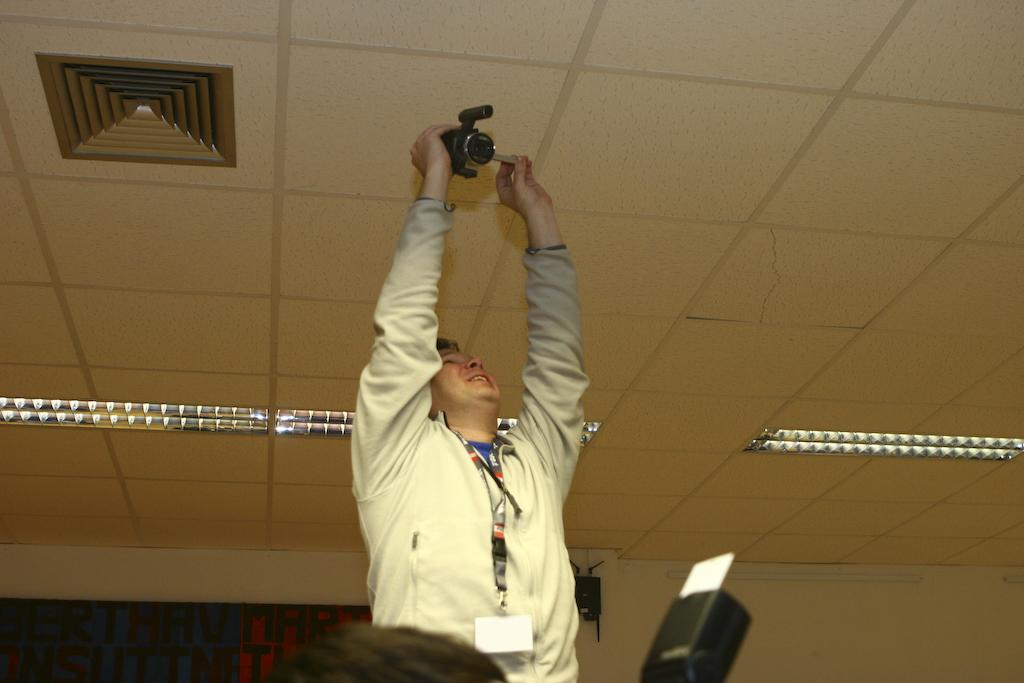What is the man in the image doing? The man is standing in the image and holding a camera in his hand. What might the man be using the camera for? The man might be using the camera to take pictures or record a video. What can be seen around the man's neck? The man is wearing an ID around his neck. What is the color of the roof in the room? The roof of the room is white in color. How many ladybugs can be seen on the man's camera? There are no ladybugs visible on the camera in the image. 